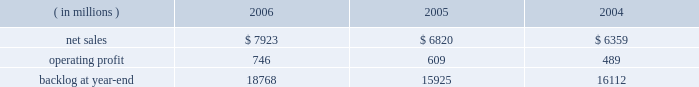Operating profit for the segment increased by 15% ( 15 % ) in 2005 compared to 2004 .
Operating profit increased by $ 80 million at m&fc mainly due to improved performance on fire control and air defense programs .
Performance on surface systems programs contributed to an increase in operating profit of $ 50 million at ms2 .
Pt&ts operating profit increased $ 10 million primarily due to improved performance on simulation and training programs .
The increase in backlog during 2006 over 2005 resulted primarily from increased orders on certain platform integration programs in pt&ts .
Space systems space systems 2019 operating results included the following : ( in millions ) 2006 2005 2004 .
Net sales for space systems increased by 16% ( 16 % ) in 2006 compared to 2005 .
During the year , sales growth in satellites and strategic & defensive missile systems ( s&dms ) offset declines in space transportation .
The $ 1.1 billion growth in satellites sales was mainly due to higher volume on both government and commercial satellite programs .
There were five commercial satellite deliveries in 2006 compared to no deliveries in 2005 .
Higher volume in both fleet ballistic missile and missile defense programs accounted for the $ 114 million sales increase at s&dms .
In space transportation , sales declined $ 102 million primarily due to lower volume in government space transportation activities on the titan and external tank programs .
Increased sales on the atlas evolved expendable launch vehicle launch capabilities ( elc ) contract partially offset the lower government space transportation sales .
Net sales for space systems increased by 7% ( 7 % ) in 2005 compared to 2004 .
During the year , sales growth in satellites and s&dms offset declines in space transportation .
The $ 410 million increase in satellites sales was due to higher volume on government satellite programs that more than offset declines in commercial satellite activities .
There were no commercial satellite deliveries in 2005 , compared to four in 2004 .
Increased sales of $ 235 million in s&dms were attributable to the fleet ballistic missile and missile defense programs .
The $ 180 million decrease in space transportation 2019s sales was mainly due to having three atlas launches in 2005 compared to six in 2004 .
Operating profit for the segment increased 22% ( 22 % ) in 2006 compared to 2005 .
Operating profit increased in satellites , space transportation and s&dms .
The $ 72 million growth in satellites operating profit was primarily driven by the volume and performance on government satellite programs and commercial satellite deliveries .
In space transportation , the $ 39 million growth in operating profit was attributable to improved performance on the atlas program resulting from risk reduction activities , including the first quarter definitization of the elc contract .
In s&dms , the $ 26 million increase in operating profit was due to higher volume and improved performance on both the fleet ballistic missile and missile defense programs .
Operating profit for the segment increased 25% ( 25 % ) in 2005 compared to 2004 .
Operating profit increased in space transportation , s&dms and satellites .
In space transportation , the $ 60 million increase in operating profit was primarily attributable to improved performance on the atlas vehicle program .
Satellites 2019 operating profit increased $ 35 million due to the higher volume and improved performance on government satellite programs , which more than offset the decreased operating profit due to the decline in commercial satellite deliveries .
The $ 20 million increase in s&dms was attributable to higher volume on fleet ballistic missile and missile defense programs .
In december 2006 , we completed a transaction with boeing to form ula , a joint venture which combines the production , engineering , test and launch operations associated with u.s .
Government launches of our atlas launch vehicles and boeing 2019s delta launch vehicles ( see related discussion on our 201cspace business 201d under 201cindustry considerations 201d ) .
We are accounting for our investment in ula under the equity method of accounting .
As a result , our share of the net earnings or losses of ula are included in other income and expenses , and we will no longer recognize sales related to launch vehicle services provided to the u.s .
Government .
In 2006 , we recorded sales to the u.s .
Government for atlas launch services totaling approximately $ 600 million .
We have retained the right to market commercial atlas launch services .
We contributed assets to ula , and ula assumed liabilities related to our atlas business in exchange for our 50% ( 50 % ) ownership interest .
The net book value of the assets contributed and liabilities assumed was approximately $ 200 million at .
What was the profit margin in 2004? 
Computations: (489 / 6359)
Answer: 0.0769. 